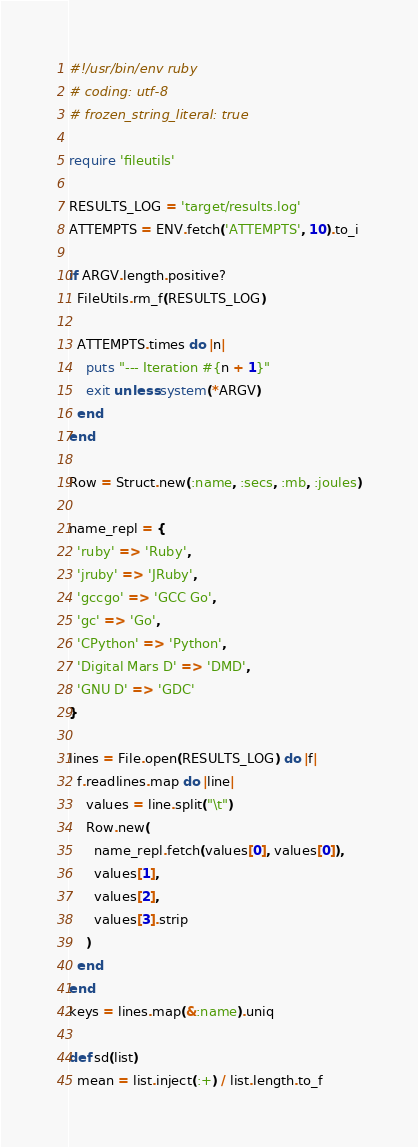<code> <loc_0><loc_0><loc_500><loc_500><_Ruby_>#!/usr/bin/env ruby
# coding: utf-8
# frozen_string_literal: true

require 'fileutils'

RESULTS_LOG = 'target/results.log'
ATTEMPTS = ENV.fetch('ATTEMPTS', 10).to_i

if ARGV.length.positive?
  FileUtils.rm_f(RESULTS_LOG)

  ATTEMPTS.times do |n|
    puts "--- Iteration #{n + 1}"
    exit unless system(*ARGV)
  end
end

Row = Struct.new(:name, :secs, :mb, :joules)

name_repl = {
  'ruby' => 'Ruby',
  'jruby' => 'JRuby',
  'gccgo' => 'GCC Go',
  'gc' => 'Go',
  'CPython' => 'Python',
  'Digital Mars D' => 'DMD',
  'GNU D' => 'GDC'
}

lines = File.open(RESULTS_LOG) do |f|
  f.readlines.map do |line|
    values = line.split("\t")
    Row.new(
      name_repl.fetch(values[0], values[0]),
      values[1],
      values[2],
      values[3].strip
    )
  end
end
keys = lines.map(&:name).uniq

def sd(list)
  mean = list.inject(:+) / list.length.to_f</code> 